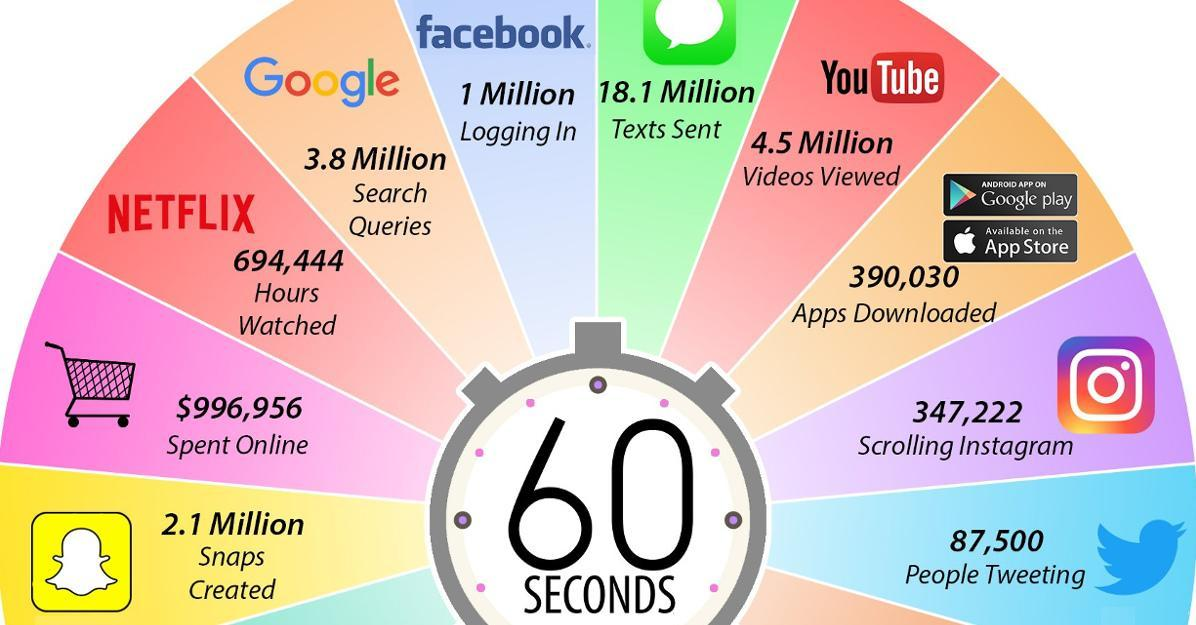How many videos were viewed in youtube in 60 seconds?
Answer the question with a short phrase. 4.5 Million How many million people are logging on facebook per 60 seconds? 1 What is the amount of money spend for online shopping per 60 seconds? $996,956 How many google search queries were made per 60 seconds? 3.8 Million How many tweets were made per 60 seconds? 87,500 